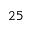<formula> <loc_0><loc_0><loc_500><loc_500>^ { 2 } 5</formula> 